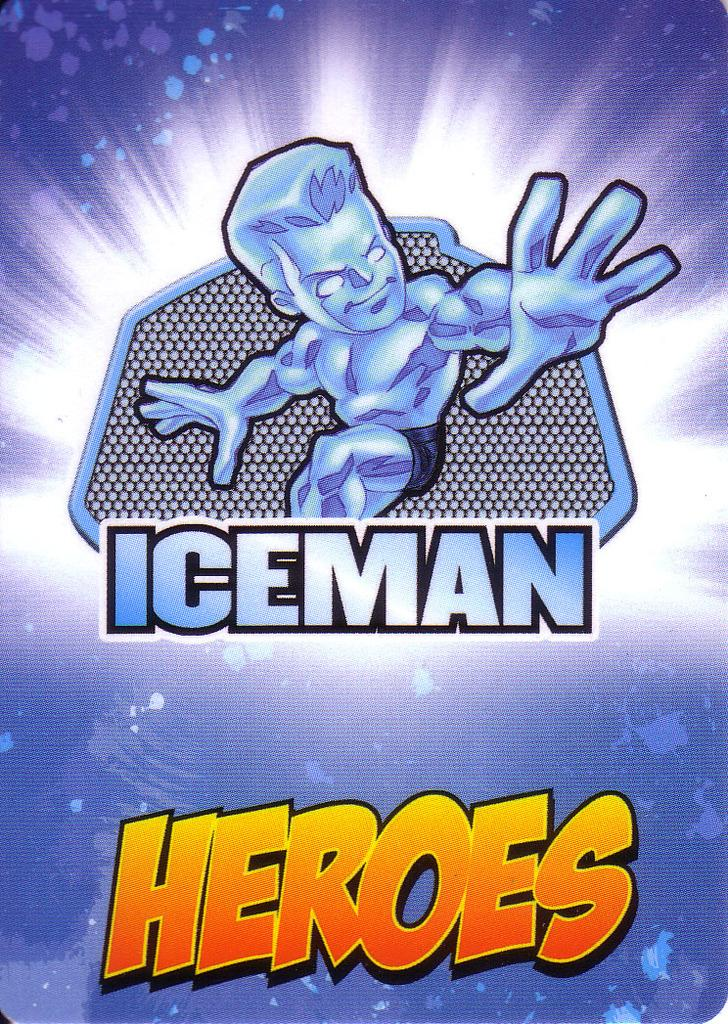<image>
Relay a brief, clear account of the picture shown. A blue and yellow cartoon image pertains to Iceman Heroes. 